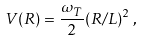Convert formula to latex. <formula><loc_0><loc_0><loc_500><loc_500>V ( R ) = \frac { \omega _ { T } } { 2 } ( R / L ) ^ { 2 } \, ,</formula> 